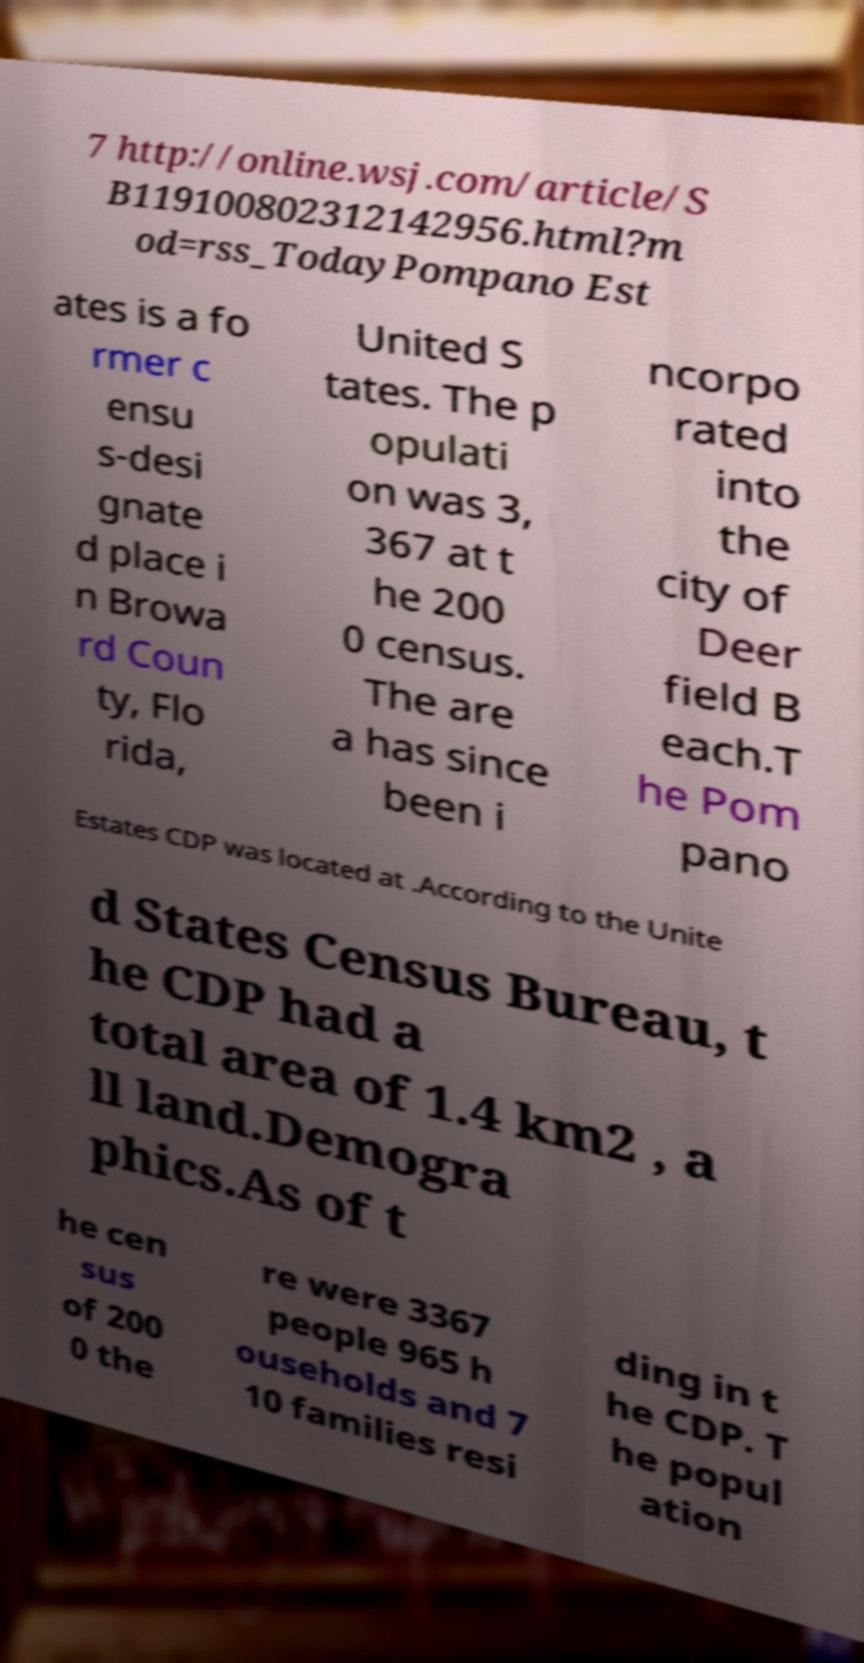There's text embedded in this image that I need extracted. Can you transcribe it verbatim? 7 http://online.wsj.com/article/S B119100802312142956.html?m od=rss_TodayPompano Est ates is a fo rmer c ensu s-desi gnate d place i n Browa rd Coun ty, Flo rida, United S tates. The p opulati on was 3, 367 at t he 200 0 census. The are a has since been i ncorpo rated into the city of Deer field B each.T he Pom pano Estates CDP was located at .According to the Unite d States Census Bureau, t he CDP had a total area of 1.4 km2 , a ll land.Demogra phics.As of t he cen sus of 200 0 the re were 3367 people 965 h ouseholds and 7 10 families resi ding in t he CDP. T he popul ation 